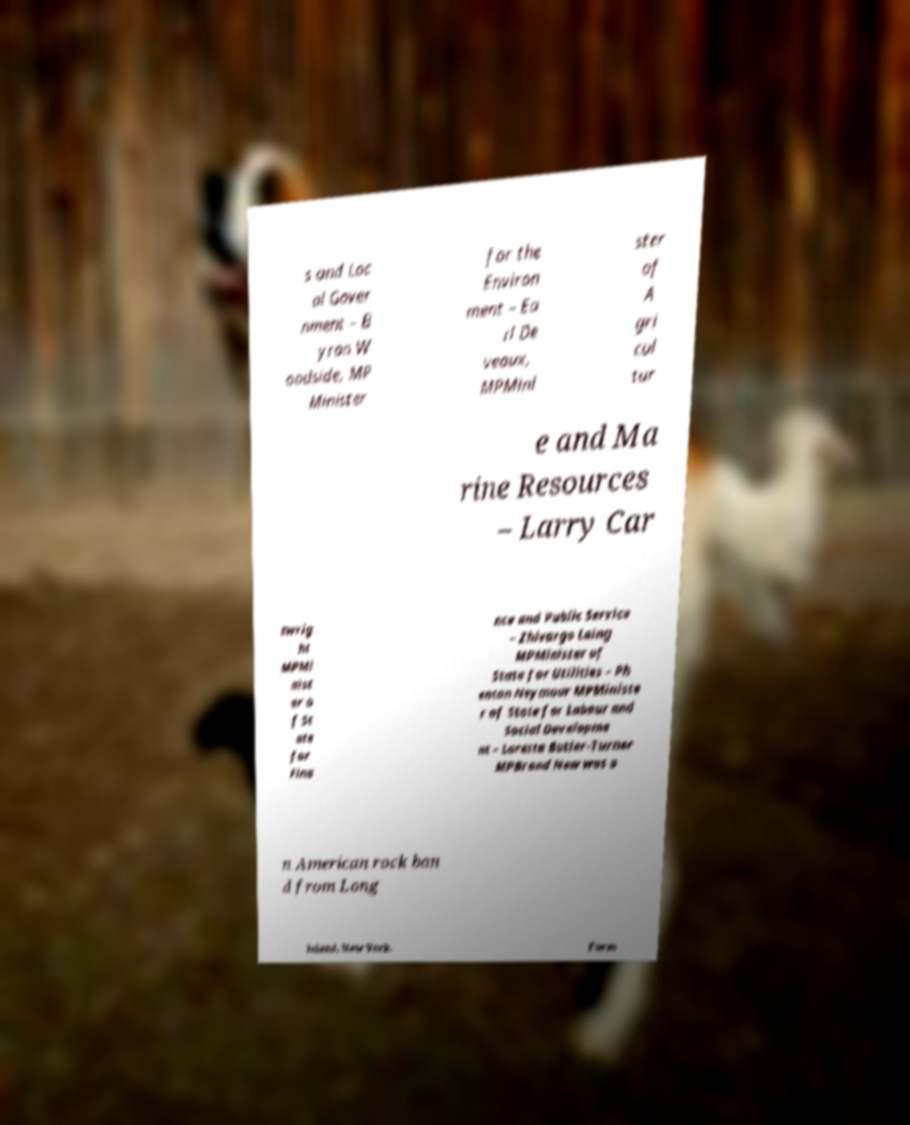Please read and relay the text visible in this image. What does it say? s and Loc al Gover nment – B yran W oodside, MP Minister for the Environ ment – Ea rl De veaux, MPMini ster of A gri cul tur e and Ma rine Resources – Larry Car twrig ht MPMi nist er o f St ate for Fina nce and Public Service – Zhivargo Laing MPMinister of State for Utilities – Ph enton Neymour MPMiniste r of State for Labour and Social Developme nt – Loretta Butler-Turner MPBrand New was a n American rock ban d from Long Island, New York. Form 